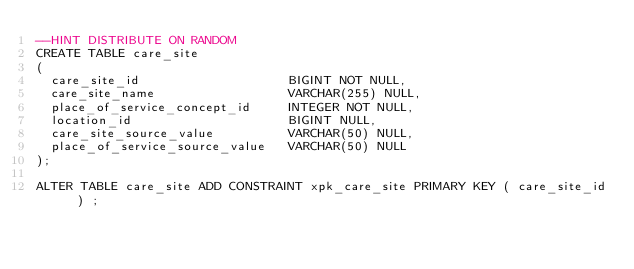Convert code to text. <code><loc_0><loc_0><loc_500><loc_500><_SQL_>--HINT DISTRIBUTE ON RANDOM
CREATE TABLE care_site
(
  care_site_id                    BIGINT NOT NULL,
  care_site_name                  VARCHAR(255) NULL,
  place_of_service_concept_id     INTEGER NOT NULL,
  location_id                     BIGINT NULL,
  care_site_source_value          VARCHAR(50) NULL,
  place_of_service_source_value   VARCHAR(50) NULL
);

ALTER TABLE care_site ADD CONSTRAINT xpk_care_site PRIMARY KEY ( care_site_id ) ;
</code> 